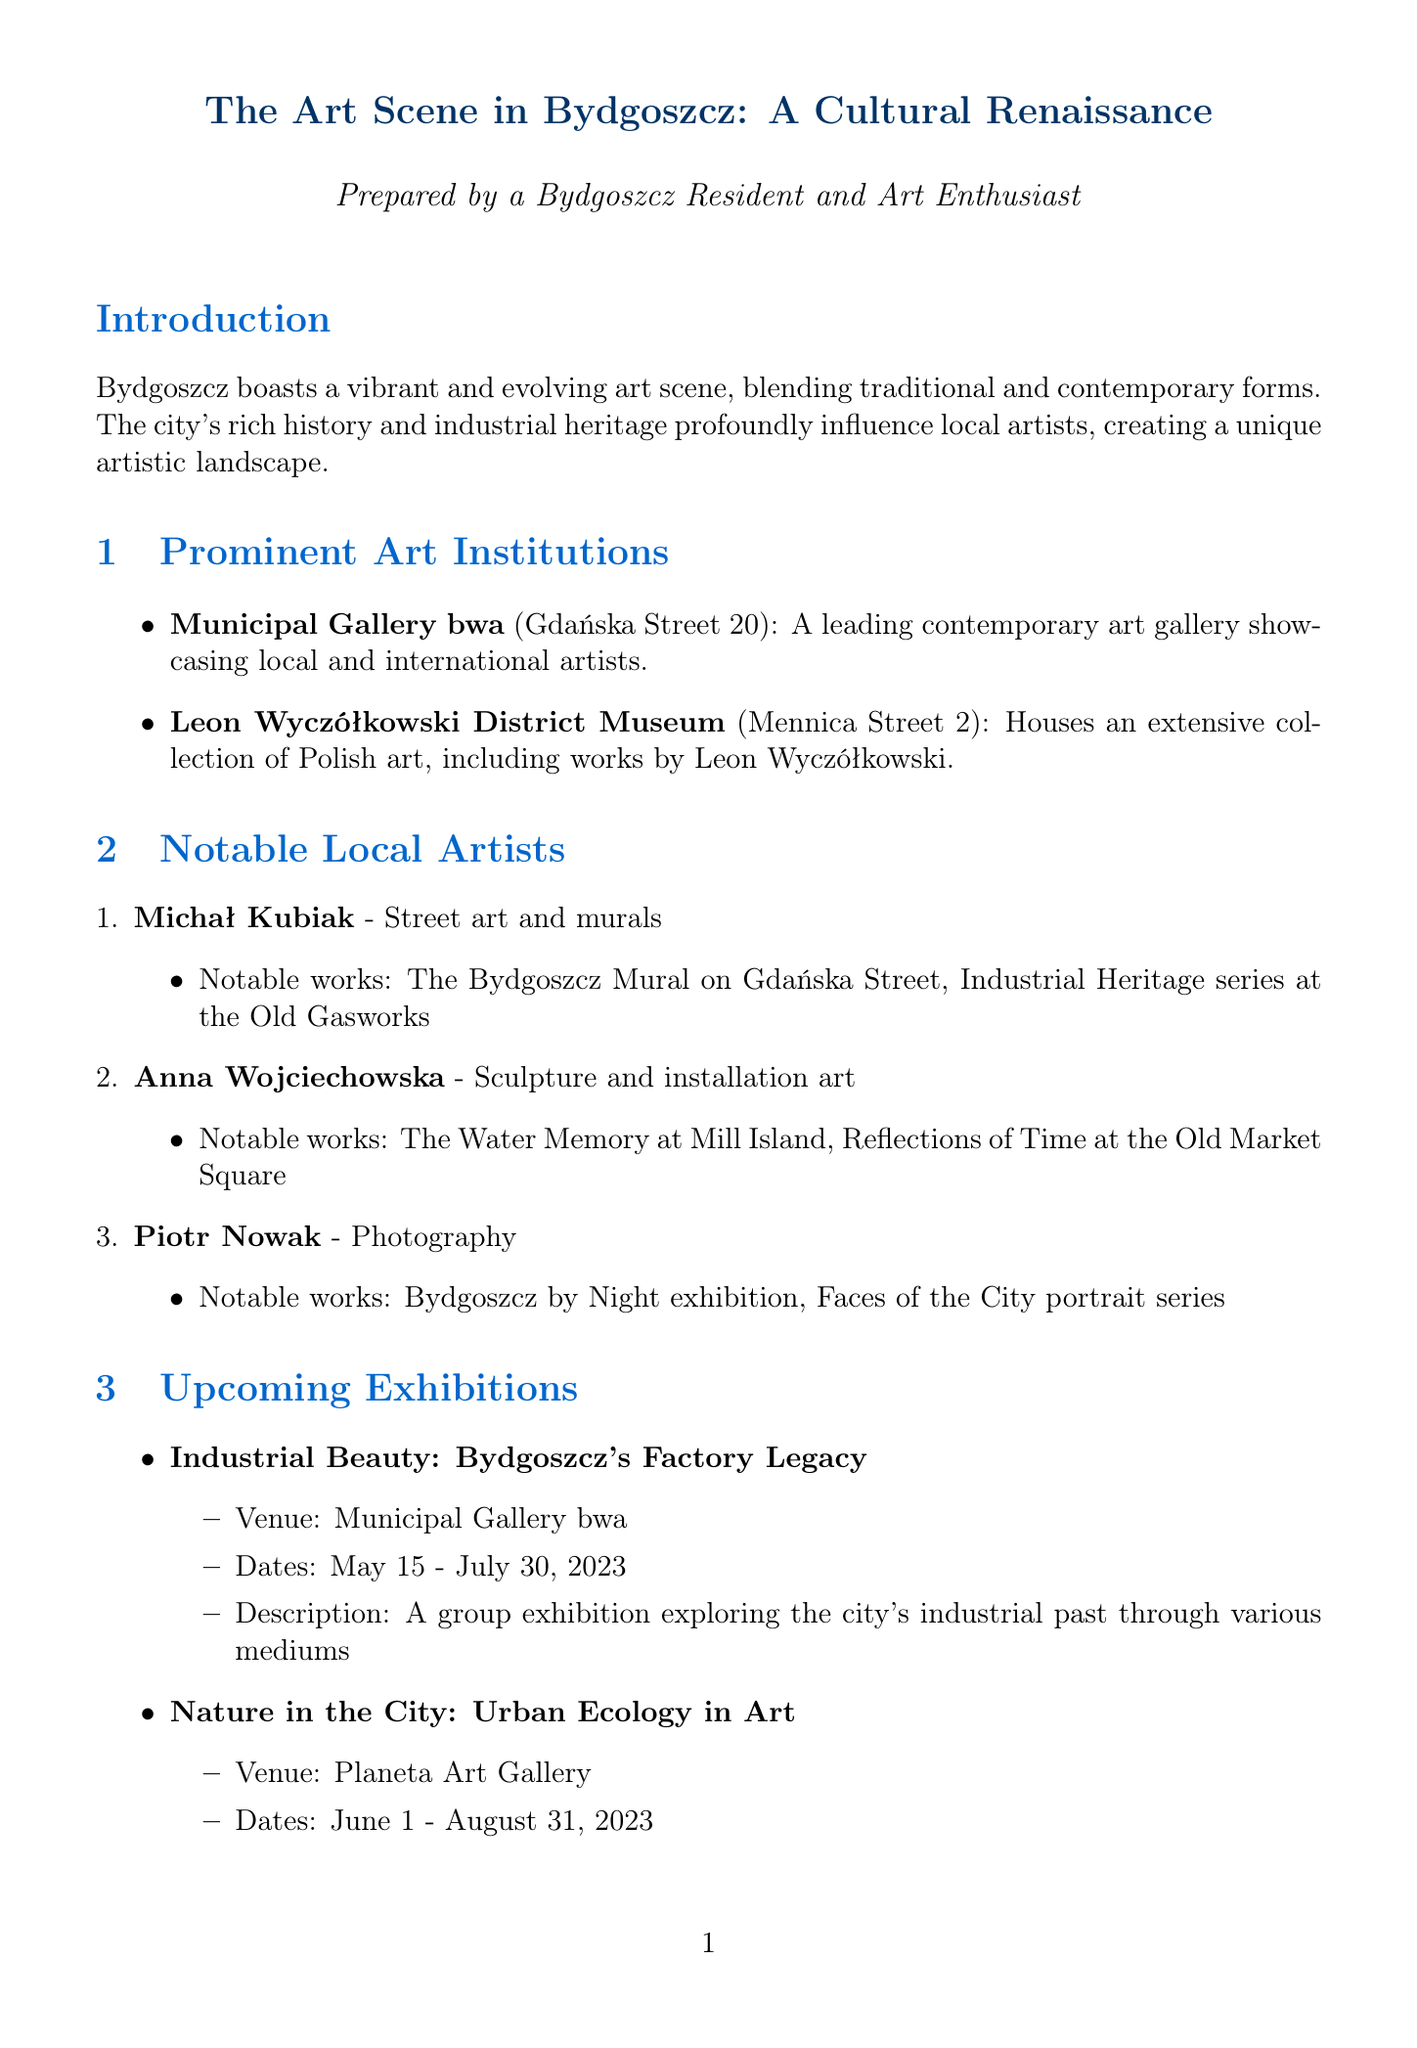What is the location of the Municipal Gallery bwa? The document states that the Municipal Gallery bwa is located on Gdańska Street 20.
Answer: Gdańska Street 20 Who is known for street art and murals? The document lists Michał Kubiak as an artist specializing in street art and murals.
Answer: Michał Kubiak What are the dates for the exhibition "Nature in the City: Urban Ecology in Art"? The document details that this exhibition runs from June 1 to August 31, 2023.
Answer: June 1 - August 31, 2023 Which artist's work includes "The Water Memory"? Anna Wojciechowska is mentioned as the artist who created "The Water Memory."
Answer: Anna Wojciechowska What is a current emerging trend in Bydgoszcz's art scene? The document highlights the integration of technology and traditional art forms as an emerging trend in the art scene.
Answer: Integration of technology and traditional art forms What is the name of the annual outdoor art festival? The document states that the annual outdoor art festival is called Bydgoszcz Art Open.
Answer: Bydgoszcz Art Open How long is the retrospective exhibition on Leon Wyczółkowski? According to the document, the retrospective runs from July 10 to September 30, 2023, which is a duration of 81 days.
Answer: 81 days Which street is home to the Leon Wyczółkowski District Museum? The document indicates that the museum is located on Mennica Street 2.
Answer: Mennica Street 2 